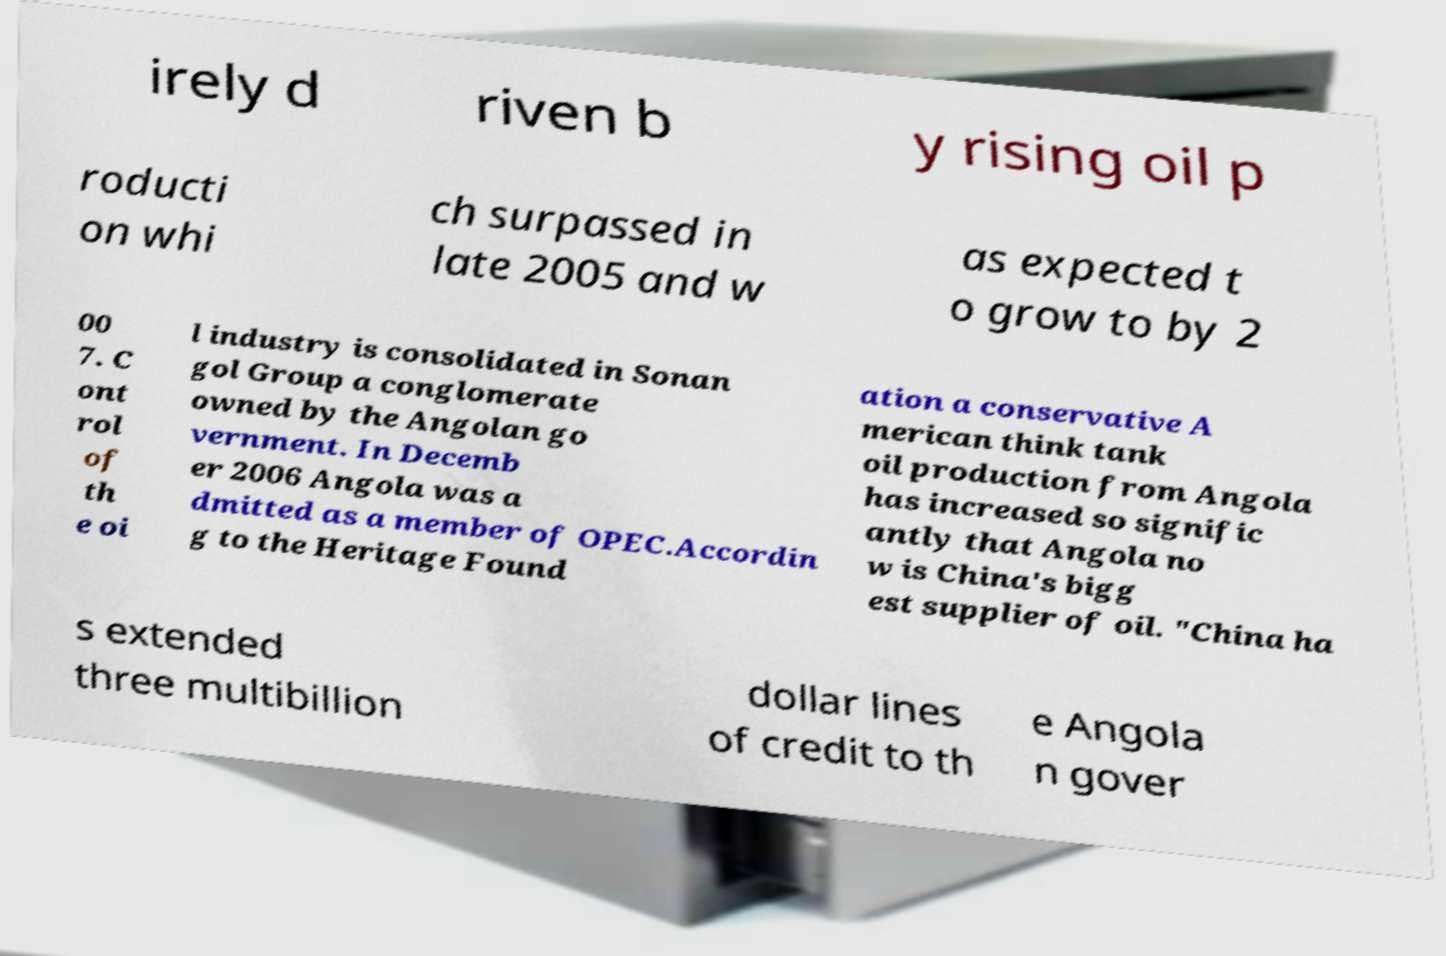Please read and relay the text visible in this image. What does it say? irely d riven b y rising oil p roducti on whi ch surpassed in late 2005 and w as expected t o grow to by 2 00 7. C ont rol of th e oi l industry is consolidated in Sonan gol Group a conglomerate owned by the Angolan go vernment. In Decemb er 2006 Angola was a dmitted as a member of OPEC.Accordin g to the Heritage Found ation a conservative A merican think tank oil production from Angola has increased so signific antly that Angola no w is China's bigg est supplier of oil. "China ha s extended three multibillion dollar lines of credit to th e Angola n gover 